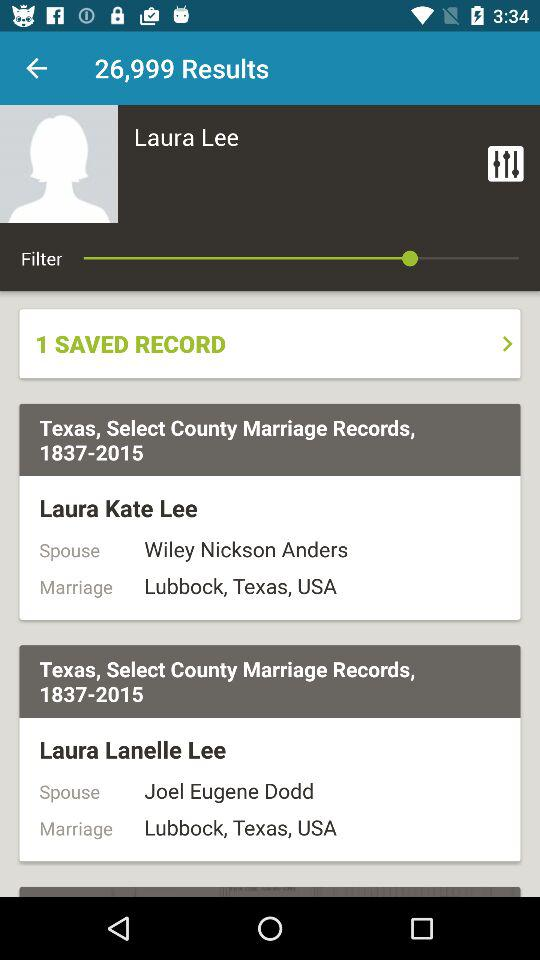How many marriage records are there for Laura Lee?
Answer the question using a single word or phrase. 2 